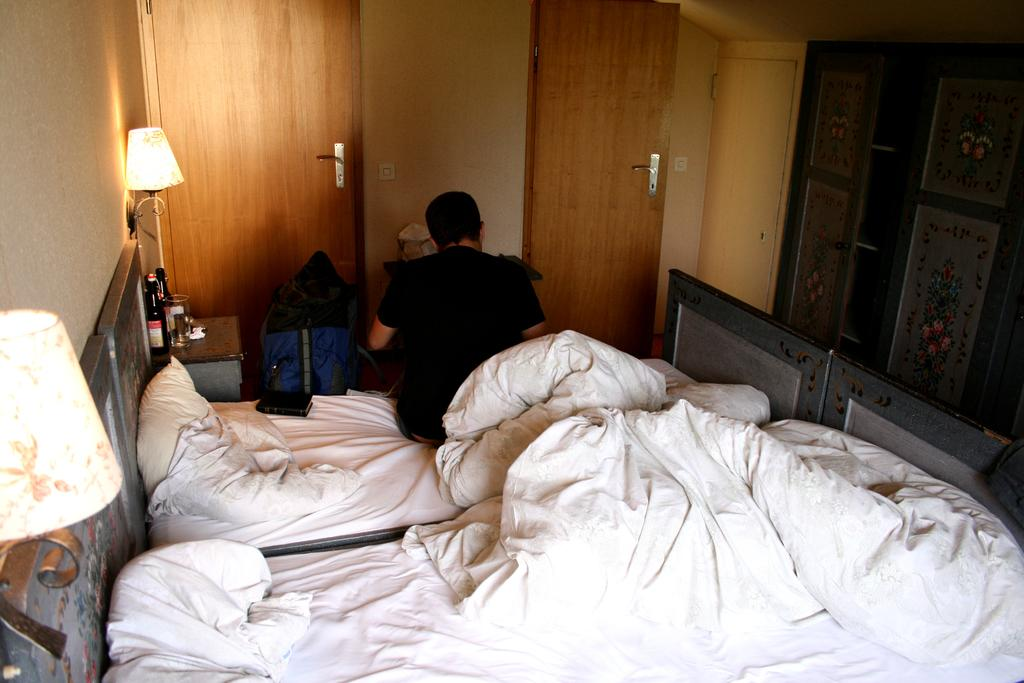What type of structure can be seen in the image? There is a wall in the image. Are there any openings in the wall? Yes, there are doors in the image. What type of lighting is present in the image? There is a lamp in the image. What is the man in the image doing? The man is sitting on a bed in the image. What is the man holding in the image? There is a bag in the image. What type of containers are visible in the image? There are bottles in the image. What type of drinking vessel is present in the image? There is a glass in the image. What color is the bed sheet on the bed? The bed sheet on the bed is white-colored. What type of cushioning is present on the bed? The bed has pillows. Can you see any oatmeal being prepared in the image? There is no oatmeal or any indication of food preparation in the image. Is there a snail crawling on the wall in the image? There is no snail present in the image. 